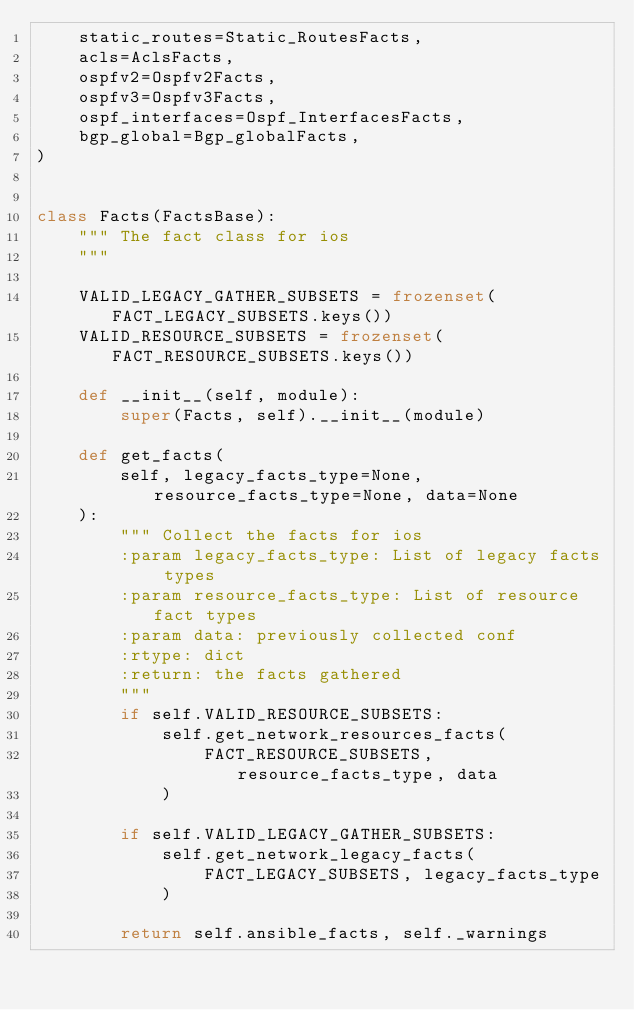Convert code to text. <code><loc_0><loc_0><loc_500><loc_500><_Python_>    static_routes=Static_RoutesFacts,
    acls=AclsFacts,
    ospfv2=Ospfv2Facts,
    ospfv3=Ospfv3Facts,
    ospf_interfaces=Ospf_InterfacesFacts,
    bgp_global=Bgp_globalFacts,
)


class Facts(FactsBase):
    """ The fact class for ios
    """

    VALID_LEGACY_GATHER_SUBSETS = frozenset(FACT_LEGACY_SUBSETS.keys())
    VALID_RESOURCE_SUBSETS = frozenset(FACT_RESOURCE_SUBSETS.keys())

    def __init__(self, module):
        super(Facts, self).__init__(module)

    def get_facts(
        self, legacy_facts_type=None, resource_facts_type=None, data=None
    ):
        """ Collect the facts for ios
        :param legacy_facts_type: List of legacy facts types
        :param resource_facts_type: List of resource fact types
        :param data: previously collected conf
        :rtype: dict
        :return: the facts gathered
        """
        if self.VALID_RESOURCE_SUBSETS:
            self.get_network_resources_facts(
                FACT_RESOURCE_SUBSETS, resource_facts_type, data
            )

        if self.VALID_LEGACY_GATHER_SUBSETS:
            self.get_network_legacy_facts(
                FACT_LEGACY_SUBSETS, legacy_facts_type
            )

        return self.ansible_facts, self._warnings
</code> 